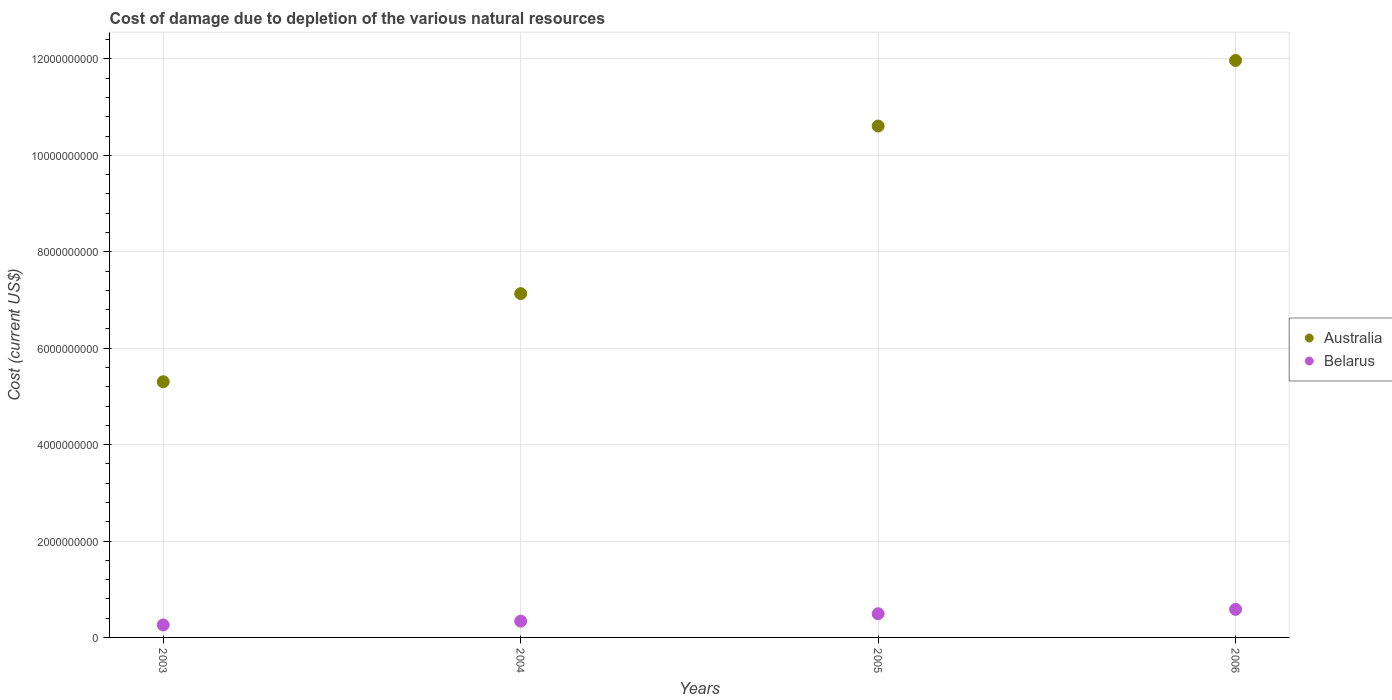Is the number of dotlines equal to the number of legend labels?
Keep it short and to the point. Yes. What is the cost of damage caused due to the depletion of various natural resources in Belarus in 2005?
Your response must be concise. 4.91e+08. Across all years, what is the maximum cost of damage caused due to the depletion of various natural resources in Belarus?
Provide a succinct answer. 5.82e+08. Across all years, what is the minimum cost of damage caused due to the depletion of various natural resources in Australia?
Provide a succinct answer. 5.30e+09. In which year was the cost of damage caused due to the depletion of various natural resources in Australia maximum?
Your answer should be very brief. 2006. What is the total cost of damage caused due to the depletion of various natural resources in Belarus in the graph?
Keep it short and to the point. 1.67e+09. What is the difference between the cost of damage caused due to the depletion of various natural resources in Australia in 2004 and that in 2005?
Your answer should be compact. -3.48e+09. What is the difference between the cost of damage caused due to the depletion of various natural resources in Belarus in 2004 and the cost of damage caused due to the depletion of various natural resources in Australia in 2005?
Offer a very short reply. -1.03e+1. What is the average cost of damage caused due to the depletion of various natural resources in Belarus per year?
Provide a short and direct response. 4.18e+08. In the year 2005, what is the difference between the cost of damage caused due to the depletion of various natural resources in Belarus and cost of damage caused due to the depletion of various natural resources in Australia?
Your answer should be compact. -1.01e+1. What is the ratio of the cost of damage caused due to the depletion of various natural resources in Australia in 2003 to that in 2004?
Offer a terse response. 0.74. Is the cost of damage caused due to the depletion of various natural resources in Belarus in 2003 less than that in 2005?
Offer a terse response. Yes. What is the difference between the highest and the second highest cost of damage caused due to the depletion of various natural resources in Belarus?
Make the answer very short. 9.09e+07. What is the difference between the highest and the lowest cost of damage caused due to the depletion of various natural resources in Australia?
Make the answer very short. 6.66e+09. In how many years, is the cost of damage caused due to the depletion of various natural resources in Australia greater than the average cost of damage caused due to the depletion of various natural resources in Australia taken over all years?
Make the answer very short. 2. Is the sum of the cost of damage caused due to the depletion of various natural resources in Australia in 2003 and 2004 greater than the maximum cost of damage caused due to the depletion of various natural resources in Belarus across all years?
Your answer should be very brief. Yes. Does the cost of damage caused due to the depletion of various natural resources in Australia monotonically increase over the years?
Provide a short and direct response. Yes. Is the cost of damage caused due to the depletion of various natural resources in Australia strictly greater than the cost of damage caused due to the depletion of various natural resources in Belarus over the years?
Your response must be concise. Yes. How many dotlines are there?
Make the answer very short. 2. How many years are there in the graph?
Provide a succinct answer. 4. What is the difference between two consecutive major ticks on the Y-axis?
Make the answer very short. 2.00e+09. Are the values on the major ticks of Y-axis written in scientific E-notation?
Ensure brevity in your answer.  No. How many legend labels are there?
Your response must be concise. 2. How are the legend labels stacked?
Provide a short and direct response. Vertical. What is the title of the graph?
Provide a short and direct response. Cost of damage due to depletion of the various natural resources. Does "Swaziland" appear as one of the legend labels in the graph?
Give a very brief answer. No. What is the label or title of the Y-axis?
Ensure brevity in your answer.  Cost (current US$). What is the Cost (current US$) in Australia in 2003?
Keep it short and to the point. 5.30e+09. What is the Cost (current US$) of Belarus in 2003?
Provide a short and direct response. 2.59e+08. What is the Cost (current US$) in Australia in 2004?
Provide a succinct answer. 7.13e+09. What is the Cost (current US$) in Belarus in 2004?
Your answer should be compact. 3.38e+08. What is the Cost (current US$) in Australia in 2005?
Provide a succinct answer. 1.06e+1. What is the Cost (current US$) of Belarus in 2005?
Make the answer very short. 4.91e+08. What is the Cost (current US$) in Australia in 2006?
Provide a short and direct response. 1.20e+1. What is the Cost (current US$) in Belarus in 2006?
Give a very brief answer. 5.82e+08. Across all years, what is the maximum Cost (current US$) of Australia?
Give a very brief answer. 1.20e+1. Across all years, what is the maximum Cost (current US$) in Belarus?
Your response must be concise. 5.82e+08. Across all years, what is the minimum Cost (current US$) in Australia?
Your answer should be compact. 5.30e+09. Across all years, what is the minimum Cost (current US$) of Belarus?
Give a very brief answer. 2.59e+08. What is the total Cost (current US$) in Australia in the graph?
Give a very brief answer. 3.50e+1. What is the total Cost (current US$) in Belarus in the graph?
Keep it short and to the point. 1.67e+09. What is the difference between the Cost (current US$) in Australia in 2003 and that in 2004?
Offer a very short reply. -1.83e+09. What is the difference between the Cost (current US$) in Belarus in 2003 and that in 2004?
Your response must be concise. -7.88e+07. What is the difference between the Cost (current US$) of Australia in 2003 and that in 2005?
Your answer should be compact. -5.30e+09. What is the difference between the Cost (current US$) in Belarus in 2003 and that in 2005?
Offer a very short reply. -2.33e+08. What is the difference between the Cost (current US$) in Australia in 2003 and that in 2006?
Offer a very short reply. -6.66e+09. What is the difference between the Cost (current US$) in Belarus in 2003 and that in 2006?
Ensure brevity in your answer.  -3.24e+08. What is the difference between the Cost (current US$) of Australia in 2004 and that in 2005?
Your answer should be compact. -3.48e+09. What is the difference between the Cost (current US$) in Belarus in 2004 and that in 2005?
Your answer should be very brief. -1.54e+08. What is the difference between the Cost (current US$) in Australia in 2004 and that in 2006?
Offer a very short reply. -4.84e+09. What is the difference between the Cost (current US$) of Belarus in 2004 and that in 2006?
Your response must be concise. -2.45e+08. What is the difference between the Cost (current US$) in Australia in 2005 and that in 2006?
Give a very brief answer. -1.36e+09. What is the difference between the Cost (current US$) in Belarus in 2005 and that in 2006?
Offer a terse response. -9.09e+07. What is the difference between the Cost (current US$) of Australia in 2003 and the Cost (current US$) of Belarus in 2004?
Your response must be concise. 4.97e+09. What is the difference between the Cost (current US$) in Australia in 2003 and the Cost (current US$) in Belarus in 2005?
Offer a very short reply. 4.81e+09. What is the difference between the Cost (current US$) in Australia in 2003 and the Cost (current US$) in Belarus in 2006?
Your answer should be very brief. 4.72e+09. What is the difference between the Cost (current US$) of Australia in 2004 and the Cost (current US$) of Belarus in 2005?
Your answer should be compact. 6.64e+09. What is the difference between the Cost (current US$) of Australia in 2004 and the Cost (current US$) of Belarus in 2006?
Your response must be concise. 6.55e+09. What is the difference between the Cost (current US$) in Australia in 2005 and the Cost (current US$) in Belarus in 2006?
Make the answer very short. 1.00e+1. What is the average Cost (current US$) in Australia per year?
Offer a terse response. 8.75e+09. What is the average Cost (current US$) of Belarus per year?
Offer a very short reply. 4.18e+08. In the year 2003, what is the difference between the Cost (current US$) in Australia and Cost (current US$) in Belarus?
Your response must be concise. 5.05e+09. In the year 2004, what is the difference between the Cost (current US$) of Australia and Cost (current US$) of Belarus?
Make the answer very short. 6.79e+09. In the year 2005, what is the difference between the Cost (current US$) of Australia and Cost (current US$) of Belarus?
Provide a succinct answer. 1.01e+1. In the year 2006, what is the difference between the Cost (current US$) in Australia and Cost (current US$) in Belarus?
Provide a succinct answer. 1.14e+1. What is the ratio of the Cost (current US$) of Australia in 2003 to that in 2004?
Ensure brevity in your answer.  0.74. What is the ratio of the Cost (current US$) of Belarus in 2003 to that in 2004?
Make the answer very short. 0.77. What is the ratio of the Cost (current US$) in Australia in 2003 to that in 2005?
Your answer should be compact. 0.5. What is the ratio of the Cost (current US$) of Belarus in 2003 to that in 2005?
Ensure brevity in your answer.  0.53. What is the ratio of the Cost (current US$) of Australia in 2003 to that in 2006?
Provide a succinct answer. 0.44. What is the ratio of the Cost (current US$) in Belarus in 2003 to that in 2006?
Offer a very short reply. 0.44. What is the ratio of the Cost (current US$) of Australia in 2004 to that in 2005?
Your answer should be very brief. 0.67. What is the ratio of the Cost (current US$) in Belarus in 2004 to that in 2005?
Offer a very short reply. 0.69. What is the ratio of the Cost (current US$) of Australia in 2004 to that in 2006?
Provide a succinct answer. 0.6. What is the ratio of the Cost (current US$) in Belarus in 2004 to that in 2006?
Offer a very short reply. 0.58. What is the ratio of the Cost (current US$) of Australia in 2005 to that in 2006?
Make the answer very short. 0.89. What is the ratio of the Cost (current US$) in Belarus in 2005 to that in 2006?
Make the answer very short. 0.84. What is the difference between the highest and the second highest Cost (current US$) in Australia?
Keep it short and to the point. 1.36e+09. What is the difference between the highest and the second highest Cost (current US$) in Belarus?
Ensure brevity in your answer.  9.09e+07. What is the difference between the highest and the lowest Cost (current US$) of Australia?
Offer a very short reply. 6.66e+09. What is the difference between the highest and the lowest Cost (current US$) in Belarus?
Make the answer very short. 3.24e+08. 